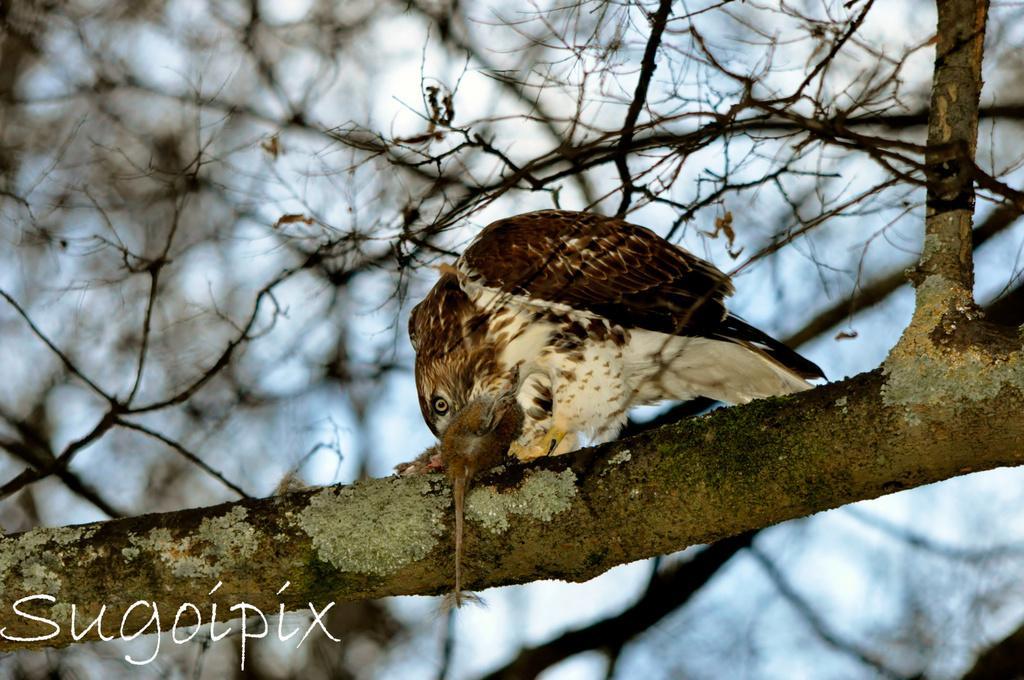Can you describe this image briefly? In this image we can see a bird holding an animal. And the bird is on a branch. In the back there are branches and it is looking blur. In the left bottom corner something is written. 